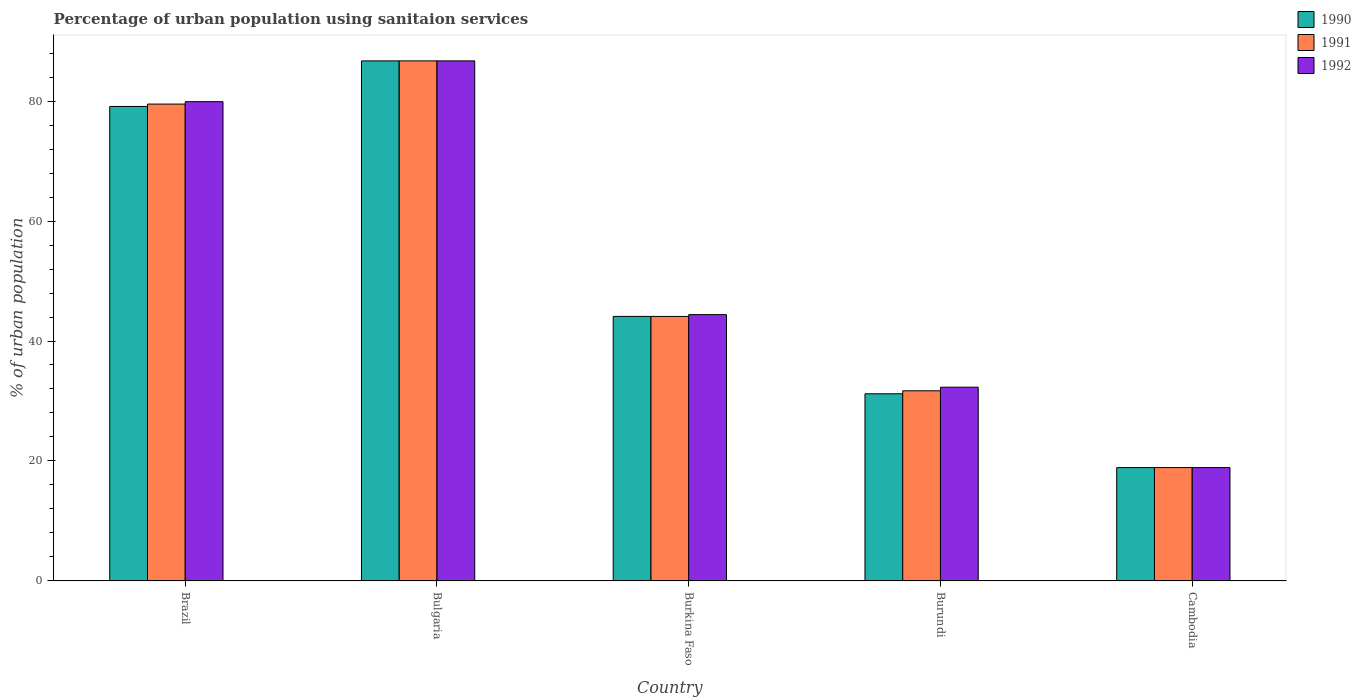Are the number of bars per tick equal to the number of legend labels?
Give a very brief answer. Yes. Are the number of bars on each tick of the X-axis equal?
Make the answer very short. Yes. How many bars are there on the 2nd tick from the right?
Keep it short and to the point. 3. What is the label of the 3rd group of bars from the left?
Your answer should be compact. Burkina Faso. What is the percentage of urban population using sanitaion services in 1992 in Burkina Faso?
Keep it short and to the point. 44.4. Across all countries, what is the maximum percentage of urban population using sanitaion services in 1991?
Your answer should be compact. 86.7. Across all countries, what is the minimum percentage of urban population using sanitaion services in 1990?
Give a very brief answer. 18.9. In which country was the percentage of urban population using sanitaion services in 1991 maximum?
Your response must be concise. Bulgaria. In which country was the percentage of urban population using sanitaion services in 1990 minimum?
Make the answer very short. Cambodia. What is the total percentage of urban population using sanitaion services in 1991 in the graph?
Offer a terse response. 260.9. What is the difference between the percentage of urban population using sanitaion services in 1992 in Bulgaria and that in Burkina Faso?
Ensure brevity in your answer.  42.3. What is the difference between the percentage of urban population using sanitaion services in 1991 in Burundi and the percentage of urban population using sanitaion services in 1992 in Bulgaria?
Your response must be concise. -55. What is the average percentage of urban population using sanitaion services in 1991 per country?
Offer a terse response. 52.18. What is the difference between the percentage of urban population using sanitaion services of/in 1992 and percentage of urban population using sanitaion services of/in 1991 in Burundi?
Your response must be concise. 0.6. In how many countries, is the percentage of urban population using sanitaion services in 1992 greater than 52 %?
Your answer should be very brief. 2. What is the ratio of the percentage of urban population using sanitaion services in 1991 in Bulgaria to that in Burkina Faso?
Keep it short and to the point. 1.97. Is the percentage of urban population using sanitaion services in 1992 in Brazil less than that in Cambodia?
Your answer should be very brief. No. Is the difference between the percentage of urban population using sanitaion services in 1992 in Burundi and Cambodia greater than the difference between the percentage of urban population using sanitaion services in 1991 in Burundi and Cambodia?
Keep it short and to the point. Yes. What is the difference between the highest and the second highest percentage of urban population using sanitaion services in 1991?
Give a very brief answer. -42.6. What is the difference between the highest and the lowest percentage of urban population using sanitaion services in 1992?
Your answer should be very brief. 67.8. Is the sum of the percentage of urban population using sanitaion services in 1991 in Brazil and Burundi greater than the maximum percentage of urban population using sanitaion services in 1990 across all countries?
Keep it short and to the point. Yes. Is it the case that in every country, the sum of the percentage of urban population using sanitaion services in 1991 and percentage of urban population using sanitaion services in 1990 is greater than the percentage of urban population using sanitaion services in 1992?
Ensure brevity in your answer.  Yes. Are all the bars in the graph horizontal?
Ensure brevity in your answer.  No. How many countries are there in the graph?
Your response must be concise. 5. What is the difference between two consecutive major ticks on the Y-axis?
Give a very brief answer. 20. Are the values on the major ticks of Y-axis written in scientific E-notation?
Provide a succinct answer. No. Where does the legend appear in the graph?
Give a very brief answer. Top right. How many legend labels are there?
Your answer should be very brief. 3. How are the legend labels stacked?
Offer a terse response. Vertical. What is the title of the graph?
Offer a very short reply. Percentage of urban population using sanitaion services. Does "1985" appear as one of the legend labels in the graph?
Offer a very short reply. No. What is the label or title of the X-axis?
Ensure brevity in your answer.  Country. What is the label or title of the Y-axis?
Provide a short and direct response. % of urban population. What is the % of urban population of 1990 in Brazil?
Your answer should be compact. 79.1. What is the % of urban population in 1991 in Brazil?
Offer a terse response. 79.5. What is the % of urban population of 1992 in Brazil?
Offer a terse response. 79.9. What is the % of urban population in 1990 in Bulgaria?
Give a very brief answer. 86.7. What is the % of urban population of 1991 in Bulgaria?
Offer a very short reply. 86.7. What is the % of urban population of 1992 in Bulgaria?
Provide a short and direct response. 86.7. What is the % of urban population of 1990 in Burkina Faso?
Your answer should be very brief. 44.1. What is the % of urban population of 1991 in Burkina Faso?
Your response must be concise. 44.1. What is the % of urban population in 1992 in Burkina Faso?
Offer a very short reply. 44.4. What is the % of urban population in 1990 in Burundi?
Offer a terse response. 31.2. What is the % of urban population of 1991 in Burundi?
Offer a terse response. 31.7. What is the % of urban population of 1992 in Burundi?
Offer a very short reply. 32.3. What is the % of urban population in 1990 in Cambodia?
Provide a succinct answer. 18.9. What is the % of urban population of 1991 in Cambodia?
Keep it short and to the point. 18.9. Across all countries, what is the maximum % of urban population in 1990?
Keep it short and to the point. 86.7. Across all countries, what is the maximum % of urban population of 1991?
Ensure brevity in your answer.  86.7. Across all countries, what is the maximum % of urban population of 1992?
Offer a very short reply. 86.7. Across all countries, what is the minimum % of urban population in 1991?
Give a very brief answer. 18.9. What is the total % of urban population in 1990 in the graph?
Your response must be concise. 260. What is the total % of urban population in 1991 in the graph?
Give a very brief answer. 260.9. What is the total % of urban population of 1992 in the graph?
Provide a short and direct response. 262.2. What is the difference between the % of urban population in 1991 in Brazil and that in Bulgaria?
Offer a very short reply. -7.2. What is the difference between the % of urban population of 1990 in Brazil and that in Burkina Faso?
Your answer should be very brief. 35. What is the difference between the % of urban population in 1991 in Brazil and that in Burkina Faso?
Your answer should be very brief. 35.4. What is the difference between the % of urban population in 1992 in Brazil and that in Burkina Faso?
Provide a succinct answer. 35.5. What is the difference between the % of urban population in 1990 in Brazil and that in Burundi?
Provide a succinct answer. 47.9. What is the difference between the % of urban population in 1991 in Brazil and that in Burundi?
Ensure brevity in your answer.  47.8. What is the difference between the % of urban population of 1992 in Brazil and that in Burundi?
Give a very brief answer. 47.6. What is the difference between the % of urban population in 1990 in Brazil and that in Cambodia?
Give a very brief answer. 60.2. What is the difference between the % of urban population of 1991 in Brazil and that in Cambodia?
Give a very brief answer. 60.6. What is the difference between the % of urban population of 1992 in Brazil and that in Cambodia?
Ensure brevity in your answer.  61. What is the difference between the % of urban population in 1990 in Bulgaria and that in Burkina Faso?
Keep it short and to the point. 42.6. What is the difference between the % of urban population of 1991 in Bulgaria and that in Burkina Faso?
Your response must be concise. 42.6. What is the difference between the % of urban population in 1992 in Bulgaria and that in Burkina Faso?
Give a very brief answer. 42.3. What is the difference between the % of urban population of 1990 in Bulgaria and that in Burundi?
Provide a short and direct response. 55.5. What is the difference between the % of urban population in 1992 in Bulgaria and that in Burundi?
Keep it short and to the point. 54.4. What is the difference between the % of urban population of 1990 in Bulgaria and that in Cambodia?
Keep it short and to the point. 67.8. What is the difference between the % of urban population in 1991 in Bulgaria and that in Cambodia?
Your answer should be compact. 67.8. What is the difference between the % of urban population of 1992 in Bulgaria and that in Cambodia?
Give a very brief answer. 67.8. What is the difference between the % of urban population in 1991 in Burkina Faso and that in Burundi?
Your answer should be very brief. 12.4. What is the difference between the % of urban population of 1992 in Burkina Faso and that in Burundi?
Your answer should be very brief. 12.1. What is the difference between the % of urban population in 1990 in Burkina Faso and that in Cambodia?
Offer a very short reply. 25.2. What is the difference between the % of urban population of 1991 in Burkina Faso and that in Cambodia?
Your answer should be very brief. 25.2. What is the difference between the % of urban population of 1992 in Burkina Faso and that in Cambodia?
Ensure brevity in your answer.  25.5. What is the difference between the % of urban population in 1990 in Burundi and that in Cambodia?
Your response must be concise. 12.3. What is the difference between the % of urban population in 1992 in Burundi and that in Cambodia?
Ensure brevity in your answer.  13.4. What is the difference between the % of urban population in 1990 in Brazil and the % of urban population in 1992 in Bulgaria?
Provide a short and direct response. -7.6. What is the difference between the % of urban population in 1991 in Brazil and the % of urban population in 1992 in Bulgaria?
Your response must be concise. -7.2. What is the difference between the % of urban population in 1990 in Brazil and the % of urban population in 1991 in Burkina Faso?
Offer a terse response. 35. What is the difference between the % of urban population in 1990 in Brazil and the % of urban population in 1992 in Burkina Faso?
Offer a very short reply. 34.7. What is the difference between the % of urban population of 1991 in Brazil and the % of urban population of 1992 in Burkina Faso?
Ensure brevity in your answer.  35.1. What is the difference between the % of urban population of 1990 in Brazil and the % of urban population of 1991 in Burundi?
Your answer should be very brief. 47.4. What is the difference between the % of urban population in 1990 in Brazil and the % of urban population in 1992 in Burundi?
Your answer should be compact. 46.8. What is the difference between the % of urban population in 1991 in Brazil and the % of urban population in 1992 in Burundi?
Make the answer very short. 47.2. What is the difference between the % of urban population in 1990 in Brazil and the % of urban population in 1991 in Cambodia?
Give a very brief answer. 60.2. What is the difference between the % of urban population of 1990 in Brazil and the % of urban population of 1992 in Cambodia?
Provide a short and direct response. 60.2. What is the difference between the % of urban population of 1991 in Brazil and the % of urban population of 1992 in Cambodia?
Your answer should be very brief. 60.6. What is the difference between the % of urban population in 1990 in Bulgaria and the % of urban population in 1991 in Burkina Faso?
Offer a terse response. 42.6. What is the difference between the % of urban population in 1990 in Bulgaria and the % of urban population in 1992 in Burkina Faso?
Offer a very short reply. 42.3. What is the difference between the % of urban population of 1991 in Bulgaria and the % of urban population of 1992 in Burkina Faso?
Give a very brief answer. 42.3. What is the difference between the % of urban population of 1990 in Bulgaria and the % of urban population of 1992 in Burundi?
Ensure brevity in your answer.  54.4. What is the difference between the % of urban population of 1991 in Bulgaria and the % of urban population of 1992 in Burundi?
Provide a succinct answer. 54.4. What is the difference between the % of urban population in 1990 in Bulgaria and the % of urban population in 1991 in Cambodia?
Keep it short and to the point. 67.8. What is the difference between the % of urban population of 1990 in Bulgaria and the % of urban population of 1992 in Cambodia?
Offer a very short reply. 67.8. What is the difference between the % of urban population of 1991 in Bulgaria and the % of urban population of 1992 in Cambodia?
Make the answer very short. 67.8. What is the difference between the % of urban population of 1990 in Burkina Faso and the % of urban population of 1991 in Burundi?
Provide a short and direct response. 12.4. What is the difference between the % of urban population of 1990 in Burkina Faso and the % of urban population of 1991 in Cambodia?
Offer a terse response. 25.2. What is the difference between the % of urban population of 1990 in Burkina Faso and the % of urban population of 1992 in Cambodia?
Make the answer very short. 25.2. What is the difference between the % of urban population in 1991 in Burkina Faso and the % of urban population in 1992 in Cambodia?
Provide a short and direct response. 25.2. What is the difference between the % of urban population in 1990 in Burundi and the % of urban population in 1992 in Cambodia?
Provide a succinct answer. 12.3. What is the difference between the % of urban population of 1991 in Burundi and the % of urban population of 1992 in Cambodia?
Offer a very short reply. 12.8. What is the average % of urban population in 1990 per country?
Your answer should be very brief. 52. What is the average % of urban population in 1991 per country?
Provide a short and direct response. 52.18. What is the average % of urban population of 1992 per country?
Your response must be concise. 52.44. What is the difference between the % of urban population of 1990 and % of urban population of 1992 in Brazil?
Your response must be concise. -0.8. What is the difference between the % of urban population of 1991 and % of urban population of 1992 in Brazil?
Your answer should be very brief. -0.4. What is the difference between the % of urban population in 1990 and % of urban population in 1992 in Bulgaria?
Ensure brevity in your answer.  0. What is the difference between the % of urban population in 1990 and % of urban population in 1992 in Burkina Faso?
Your answer should be compact. -0.3. What is the difference between the % of urban population of 1990 and % of urban population of 1991 in Burundi?
Make the answer very short. -0.5. What is the difference between the % of urban population in 1990 and % of urban population in 1992 in Burundi?
Your answer should be compact. -1.1. What is the difference between the % of urban population of 1990 and % of urban population of 1992 in Cambodia?
Make the answer very short. 0. What is the ratio of the % of urban population of 1990 in Brazil to that in Bulgaria?
Keep it short and to the point. 0.91. What is the ratio of the % of urban population of 1991 in Brazil to that in Bulgaria?
Ensure brevity in your answer.  0.92. What is the ratio of the % of urban population of 1992 in Brazil to that in Bulgaria?
Offer a very short reply. 0.92. What is the ratio of the % of urban population in 1990 in Brazil to that in Burkina Faso?
Make the answer very short. 1.79. What is the ratio of the % of urban population in 1991 in Brazil to that in Burkina Faso?
Provide a short and direct response. 1.8. What is the ratio of the % of urban population in 1992 in Brazil to that in Burkina Faso?
Provide a succinct answer. 1.8. What is the ratio of the % of urban population of 1990 in Brazil to that in Burundi?
Offer a very short reply. 2.54. What is the ratio of the % of urban population in 1991 in Brazil to that in Burundi?
Your answer should be compact. 2.51. What is the ratio of the % of urban population in 1992 in Brazil to that in Burundi?
Your response must be concise. 2.47. What is the ratio of the % of urban population of 1990 in Brazil to that in Cambodia?
Give a very brief answer. 4.19. What is the ratio of the % of urban population of 1991 in Brazil to that in Cambodia?
Ensure brevity in your answer.  4.21. What is the ratio of the % of urban population of 1992 in Brazil to that in Cambodia?
Make the answer very short. 4.23. What is the ratio of the % of urban population in 1990 in Bulgaria to that in Burkina Faso?
Your response must be concise. 1.97. What is the ratio of the % of urban population in 1991 in Bulgaria to that in Burkina Faso?
Provide a short and direct response. 1.97. What is the ratio of the % of urban population in 1992 in Bulgaria to that in Burkina Faso?
Ensure brevity in your answer.  1.95. What is the ratio of the % of urban population in 1990 in Bulgaria to that in Burundi?
Give a very brief answer. 2.78. What is the ratio of the % of urban population in 1991 in Bulgaria to that in Burundi?
Your answer should be very brief. 2.73. What is the ratio of the % of urban population in 1992 in Bulgaria to that in Burundi?
Ensure brevity in your answer.  2.68. What is the ratio of the % of urban population of 1990 in Bulgaria to that in Cambodia?
Provide a succinct answer. 4.59. What is the ratio of the % of urban population in 1991 in Bulgaria to that in Cambodia?
Give a very brief answer. 4.59. What is the ratio of the % of urban population in 1992 in Bulgaria to that in Cambodia?
Your answer should be very brief. 4.59. What is the ratio of the % of urban population of 1990 in Burkina Faso to that in Burundi?
Give a very brief answer. 1.41. What is the ratio of the % of urban population in 1991 in Burkina Faso to that in Burundi?
Ensure brevity in your answer.  1.39. What is the ratio of the % of urban population of 1992 in Burkina Faso to that in Burundi?
Your response must be concise. 1.37. What is the ratio of the % of urban population in 1990 in Burkina Faso to that in Cambodia?
Keep it short and to the point. 2.33. What is the ratio of the % of urban population of 1991 in Burkina Faso to that in Cambodia?
Provide a succinct answer. 2.33. What is the ratio of the % of urban population in 1992 in Burkina Faso to that in Cambodia?
Ensure brevity in your answer.  2.35. What is the ratio of the % of urban population of 1990 in Burundi to that in Cambodia?
Make the answer very short. 1.65. What is the ratio of the % of urban population of 1991 in Burundi to that in Cambodia?
Provide a short and direct response. 1.68. What is the ratio of the % of urban population in 1992 in Burundi to that in Cambodia?
Your answer should be very brief. 1.71. What is the difference between the highest and the second highest % of urban population in 1991?
Keep it short and to the point. 7.2. What is the difference between the highest and the lowest % of urban population of 1990?
Give a very brief answer. 67.8. What is the difference between the highest and the lowest % of urban population of 1991?
Provide a short and direct response. 67.8. What is the difference between the highest and the lowest % of urban population in 1992?
Keep it short and to the point. 67.8. 